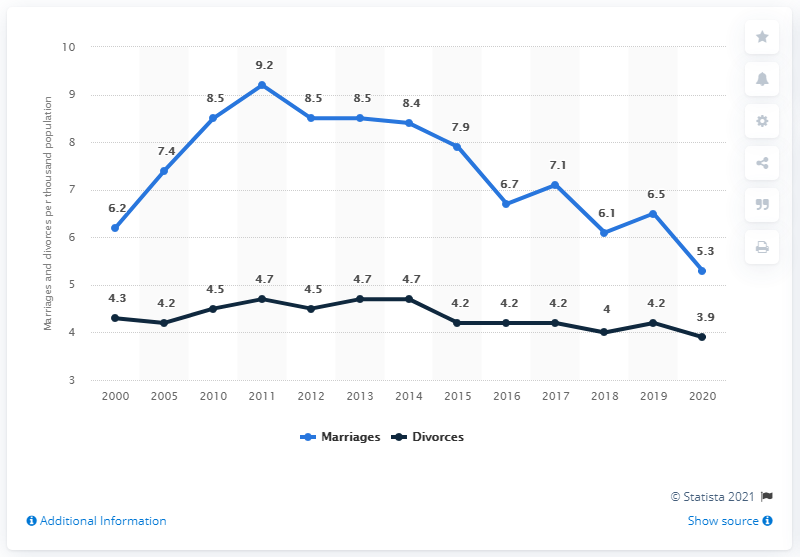Identify some key points in this picture. In 2020, the number of divorces registered per 1,000 population in Russia was 3.9. In 2010, there were 8.5 marriages registered per thousand Russians. In 2020, there were approximately 5.3 marriages registered per thousand inhabitants in Russia. 